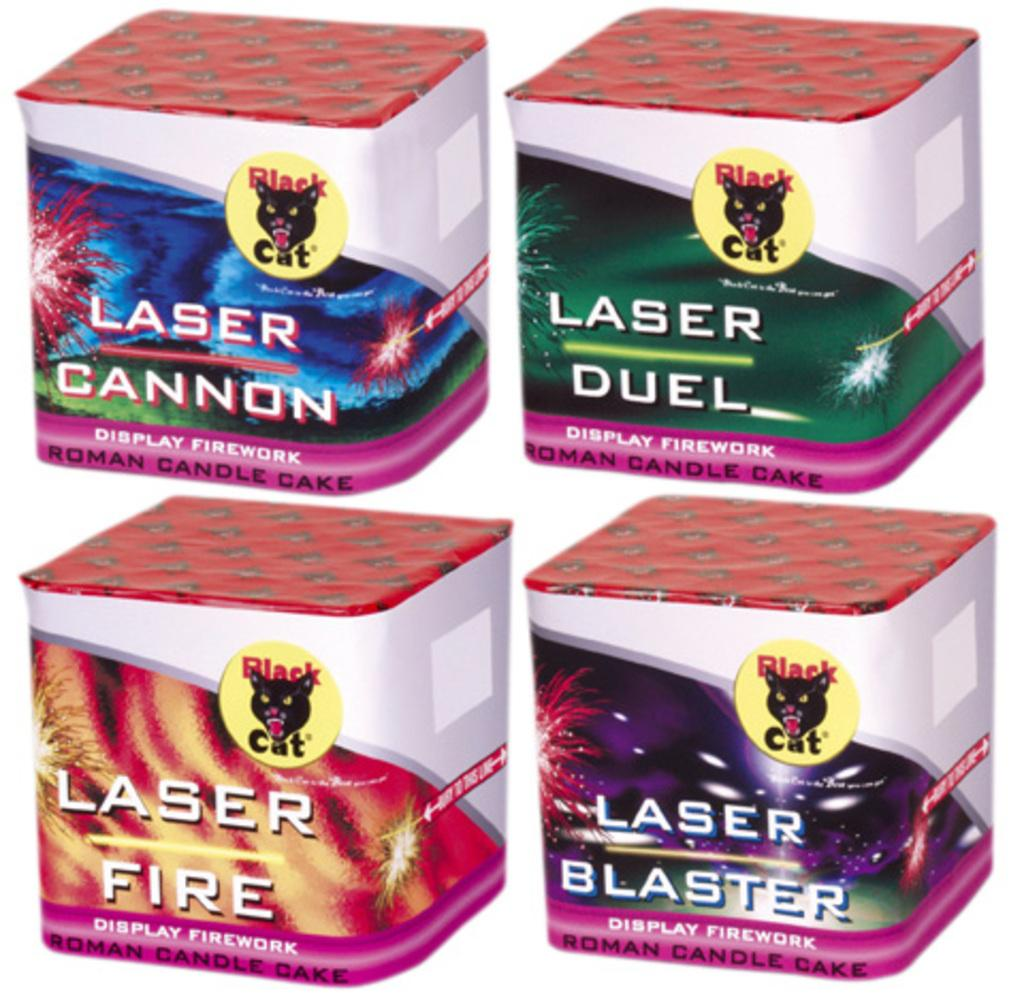<image>
Provide a brief description of the given image. four small boxes next to one another that all say 'display firework' on it 